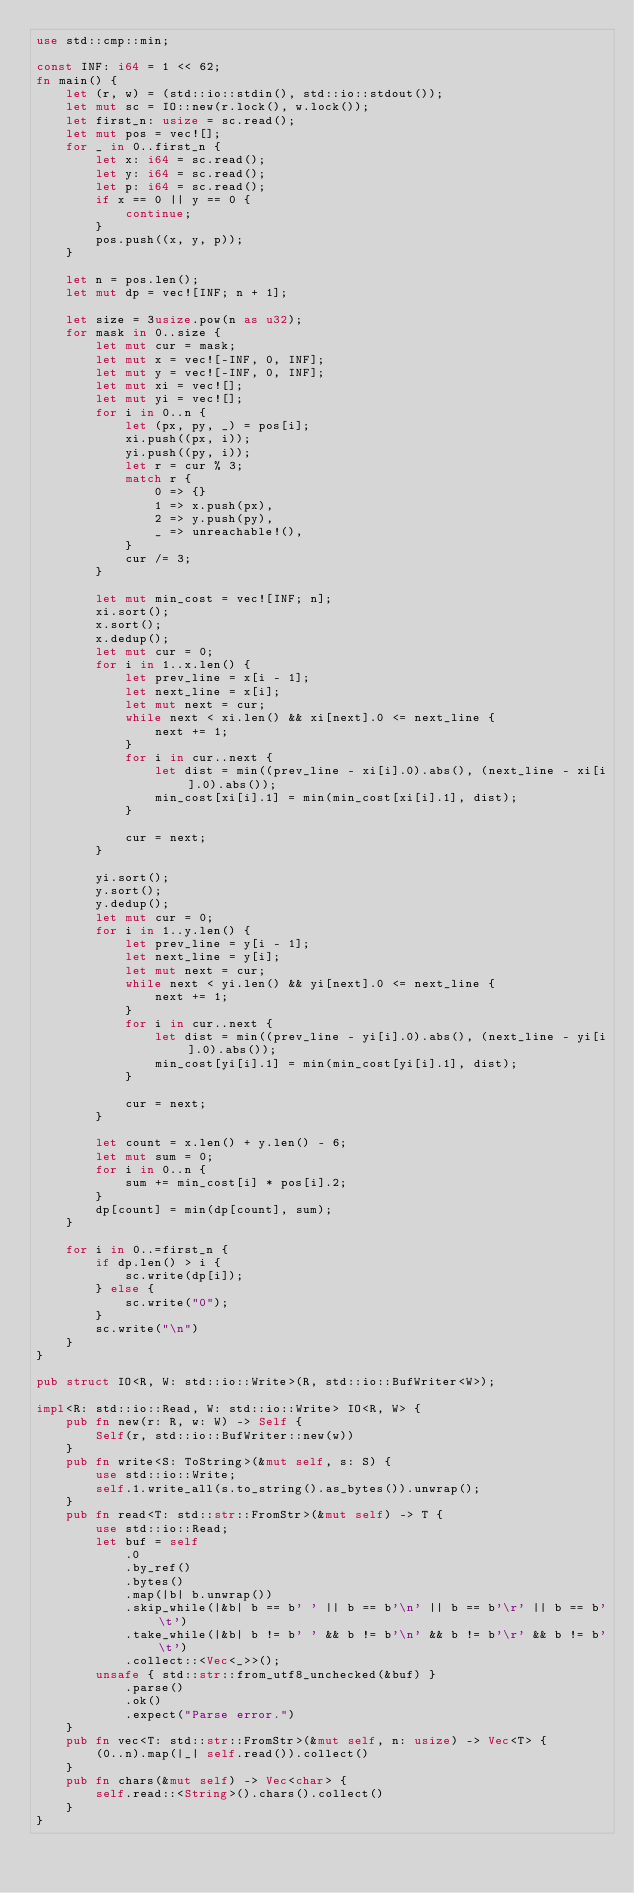Convert code to text. <code><loc_0><loc_0><loc_500><loc_500><_Rust_>use std::cmp::min;

const INF: i64 = 1 << 62;
fn main() {
    let (r, w) = (std::io::stdin(), std::io::stdout());
    let mut sc = IO::new(r.lock(), w.lock());
    let first_n: usize = sc.read();
    let mut pos = vec![];
    for _ in 0..first_n {
        let x: i64 = sc.read();
        let y: i64 = sc.read();
        let p: i64 = sc.read();
        if x == 0 || y == 0 {
            continue;
        }
        pos.push((x, y, p));
    }

    let n = pos.len();
    let mut dp = vec![INF; n + 1];

    let size = 3usize.pow(n as u32);
    for mask in 0..size {
        let mut cur = mask;
        let mut x = vec![-INF, 0, INF];
        let mut y = vec![-INF, 0, INF];
        let mut xi = vec![];
        let mut yi = vec![];
        for i in 0..n {
            let (px, py, _) = pos[i];
            xi.push((px, i));
            yi.push((py, i));
            let r = cur % 3;
            match r {
                0 => {}
                1 => x.push(px),
                2 => y.push(py),
                _ => unreachable!(),
            }
            cur /= 3;
        }

        let mut min_cost = vec![INF; n];
        xi.sort();
        x.sort();
        x.dedup();
        let mut cur = 0;
        for i in 1..x.len() {
            let prev_line = x[i - 1];
            let next_line = x[i];
            let mut next = cur;
            while next < xi.len() && xi[next].0 <= next_line {
                next += 1;
            }
            for i in cur..next {
                let dist = min((prev_line - xi[i].0).abs(), (next_line - xi[i].0).abs());
                min_cost[xi[i].1] = min(min_cost[xi[i].1], dist);
            }

            cur = next;
        }

        yi.sort();
        y.sort();
        y.dedup();
        let mut cur = 0;
        for i in 1..y.len() {
            let prev_line = y[i - 1];
            let next_line = y[i];
            let mut next = cur;
            while next < yi.len() && yi[next].0 <= next_line {
                next += 1;
            }
            for i in cur..next {
                let dist = min((prev_line - yi[i].0).abs(), (next_line - yi[i].0).abs());
                min_cost[yi[i].1] = min(min_cost[yi[i].1], dist);
            }

            cur = next;
        }

        let count = x.len() + y.len() - 6;
        let mut sum = 0;
        for i in 0..n {
            sum += min_cost[i] * pos[i].2;
        }
        dp[count] = min(dp[count], sum);
    }

    for i in 0..=first_n {
        if dp.len() > i {
            sc.write(dp[i]);
        } else {
            sc.write("0");
        }
        sc.write("\n")
    }
}

pub struct IO<R, W: std::io::Write>(R, std::io::BufWriter<W>);

impl<R: std::io::Read, W: std::io::Write> IO<R, W> {
    pub fn new(r: R, w: W) -> Self {
        Self(r, std::io::BufWriter::new(w))
    }
    pub fn write<S: ToString>(&mut self, s: S) {
        use std::io::Write;
        self.1.write_all(s.to_string().as_bytes()).unwrap();
    }
    pub fn read<T: std::str::FromStr>(&mut self) -> T {
        use std::io::Read;
        let buf = self
            .0
            .by_ref()
            .bytes()
            .map(|b| b.unwrap())
            .skip_while(|&b| b == b' ' || b == b'\n' || b == b'\r' || b == b'\t')
            .take_while(|&b| b != b' ' && b != b'\n' && b != b'\r' && b != b'\t')
            .collect::<Vec<_>>();
        unsafe { std::str::from_utf8_unchecked(&buf) }
            .parse()
            .ok()
            .expect("Parse error.")
    }
    pub fn vec<T: std::str::FromStr>(&mut self, n: usize) -> Vec<T> {
        (0..n).map(|_| self.read()).collect()
    }
    pub fn chars(&mut self) -> Vec<char> {
        self.read::<String>().chars().collect()
    }
}
</code> 